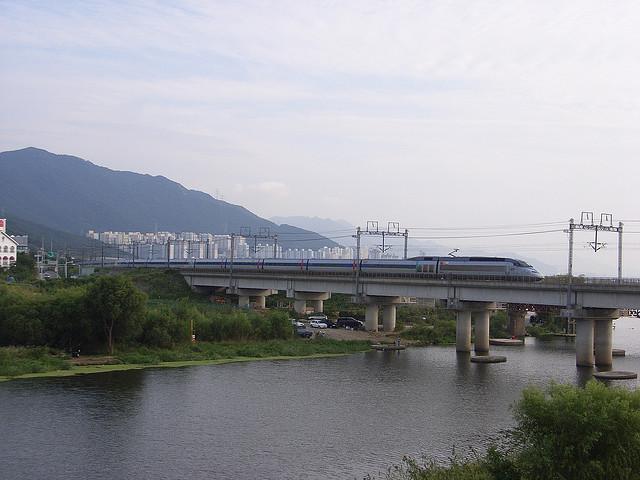How many arches are there?
Concise answer only. 5. How would a person safely drive from one back of this river to the other?
Write a very short answer. Bridge. How many pillars support the bridge?
Keep it brief. 10. Is the train in the country or in the city?
Quick response, please. City. Is there any ivy on the bridge?
Quick response, please. No. Is the train perpendicular to the river?
Keep it brief. Yes. Is the bridge a modern bridge?
Keep it brief. Yes. Is this a brand new bridge?
Answer briefly. No. What kind of bridge is in the back?
Keep it brief. Train. Was this photo taken at sunset?
Be succinct. No. What color is the train?
Write a very short answer. Gray. Is the water in the picture?
Write a very short answer. Yes. Is the train in motion?
Quick response, please. Yes. 